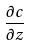<formula> <loc_0><loc_0><loc_500><loc_500>\frac { \partial c } { \partial z }</formula> 